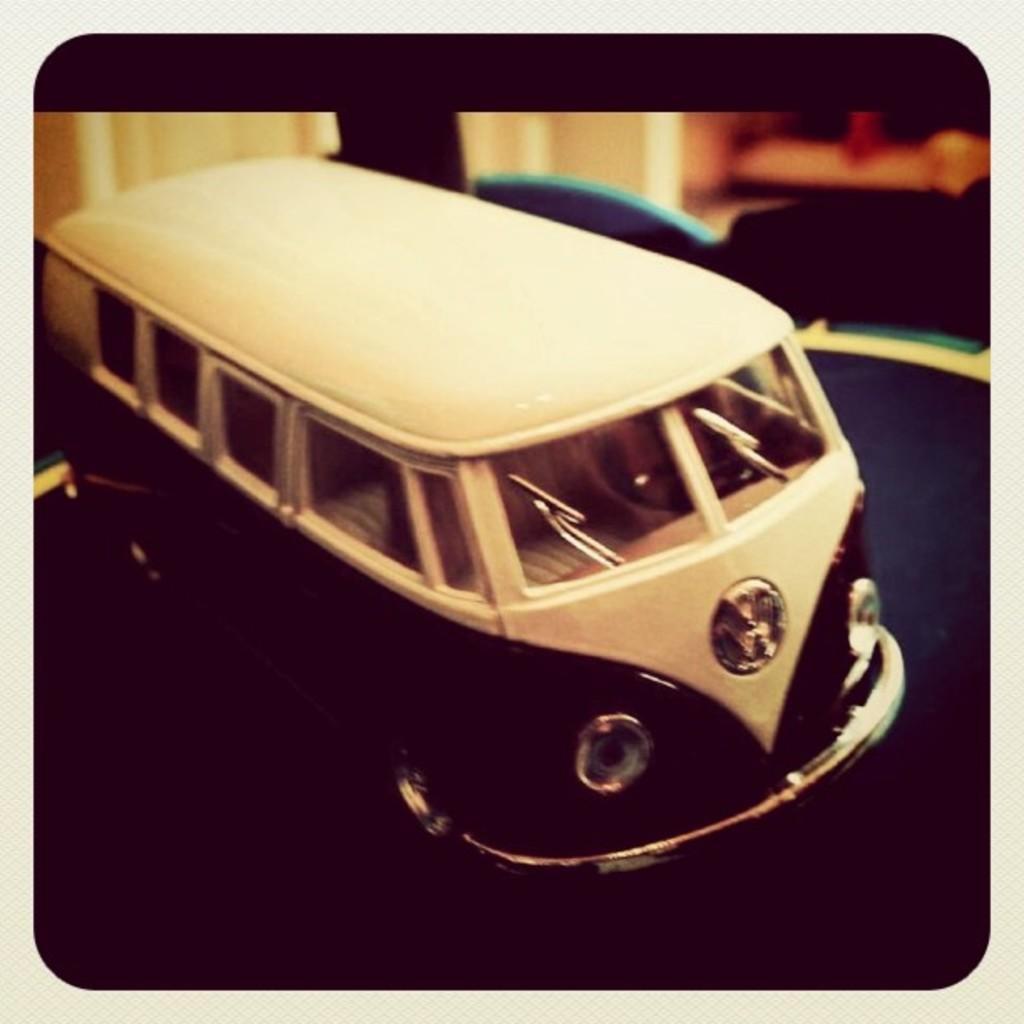Could you give a brief overview of what you see in this image? In this image, we can see a toy. We can see the ground and the blurred background. 